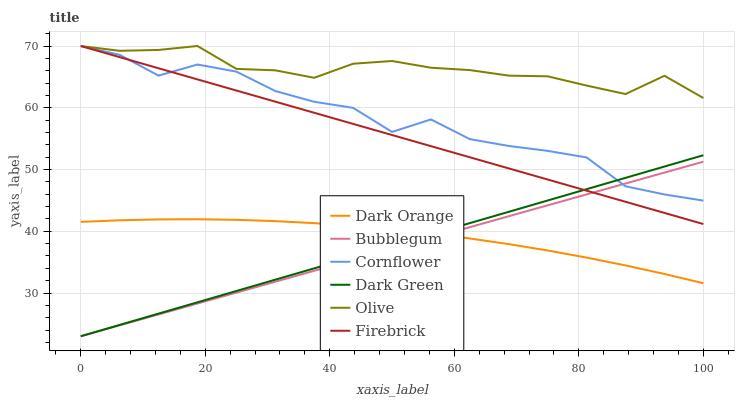Does Cornflower have the minimum area under the curve?
Answer yes or no. No. Does Cornflower have the maximum area under the curve?
Answer yes or no. No. Is Firebrick the smoothest?
Answer yes or no. No. Is Firebrick the roughest?
Answer yes or no. No. Does Cornflower have the lowest value?
Answer yes or no. No. Does Bubblegum have the highest value?
Answer yes or no. No. Is Dark Orange less than Firebrick?
Answer yes or no. Yes. Is Olive greater than Bubblegum?
Answer yes or no. Yes. Does Dark Orange intersect Firebrick?
Answer yes or no. No. 